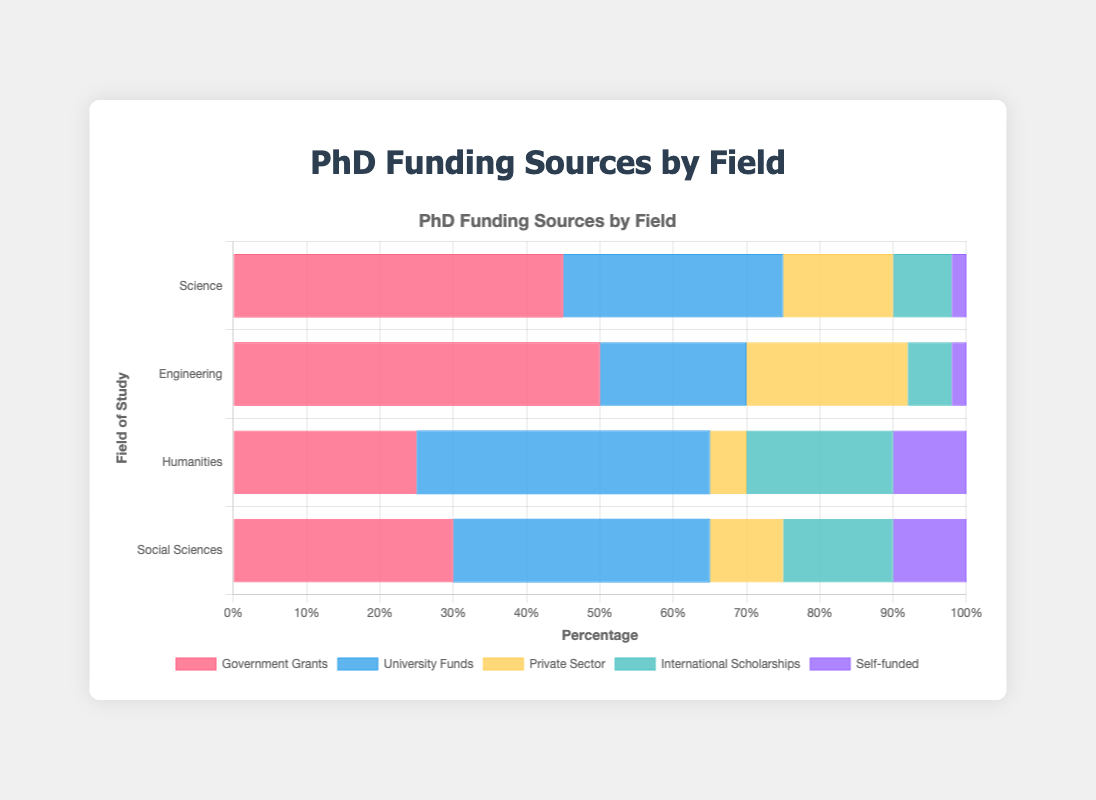What scientific field has the highest proportion of government grants usage? By observing the height of the bars representing "Government Grants," the highest bar belongs to "Engineering" with a value of 50%.
Answer: Engineering What is the total percentage of university funds used in Science and Social Sciences combined? The university funds used in Science is 30% and in Social Sciences is 35%. Adding these together gives 30 + 35 = 65.
Answer: 65% Which funding source contributes the least to Engineering research? By looking at the smallest bar for Engineering, we see that "Self-funded" has the smallest proportion at 2%.
Answer: Self-funded Compare the proportion of private sector funding between Science and Humanities. Which field has a higher percentage? The private sector funding in Science is 15% and in Humanities is 5%. Since 15 > 5, Science has a higher percentage.
Answer: Science What is the difference in the percentage of international scholarships between Humanities and Social Sciences? The percentage of international scholarships in Humanities is 20% and in Social Sciences is 15%. Subtracting these, we get 20 - 15 = 5.
Answer: 5% What field relies most heavily on self-funding? The highest percentage of "Self-funded" is in both Humanities and Social Sciences, each with 10%.
Answer: Humanities and Social Sciences What is the average percentage of university funds usage across all fields? The university funds used are 30% in Science, 20% in Engineering, 40% in Humanities, and 35% in Social Sciences. Adding these values gives 30 + 20 + 40 + 35 = 125. Dividing by 4 fields, we get 125 / 4 = 31.25.
Answer: 31.25% Compare the combined usage of government grants and private sector funding in Humanities. What is the total percentage? Government grants in Humanities is 25%, and private sector funding is 5%. Adding these together gives 25 + 5 = 30.
Answer: 30% Which field has the lowest total percentage for international scholarships? By comparing the bar lengths for "International Scholarships," Engineering has the lowest at 6%.
Answer: Engineering If you add the percentages of all funding sources in Social Sciences, what is the result? The percentages in Social Sciences are 30% (Government Grants), 35% (University Funds), 10% (Private Sector), 15% (International Scholarships), and 10% (Self-funded). Adding these gives 30 + 35 + 10 + 15 + 10 = 100.
Answer: 100% 